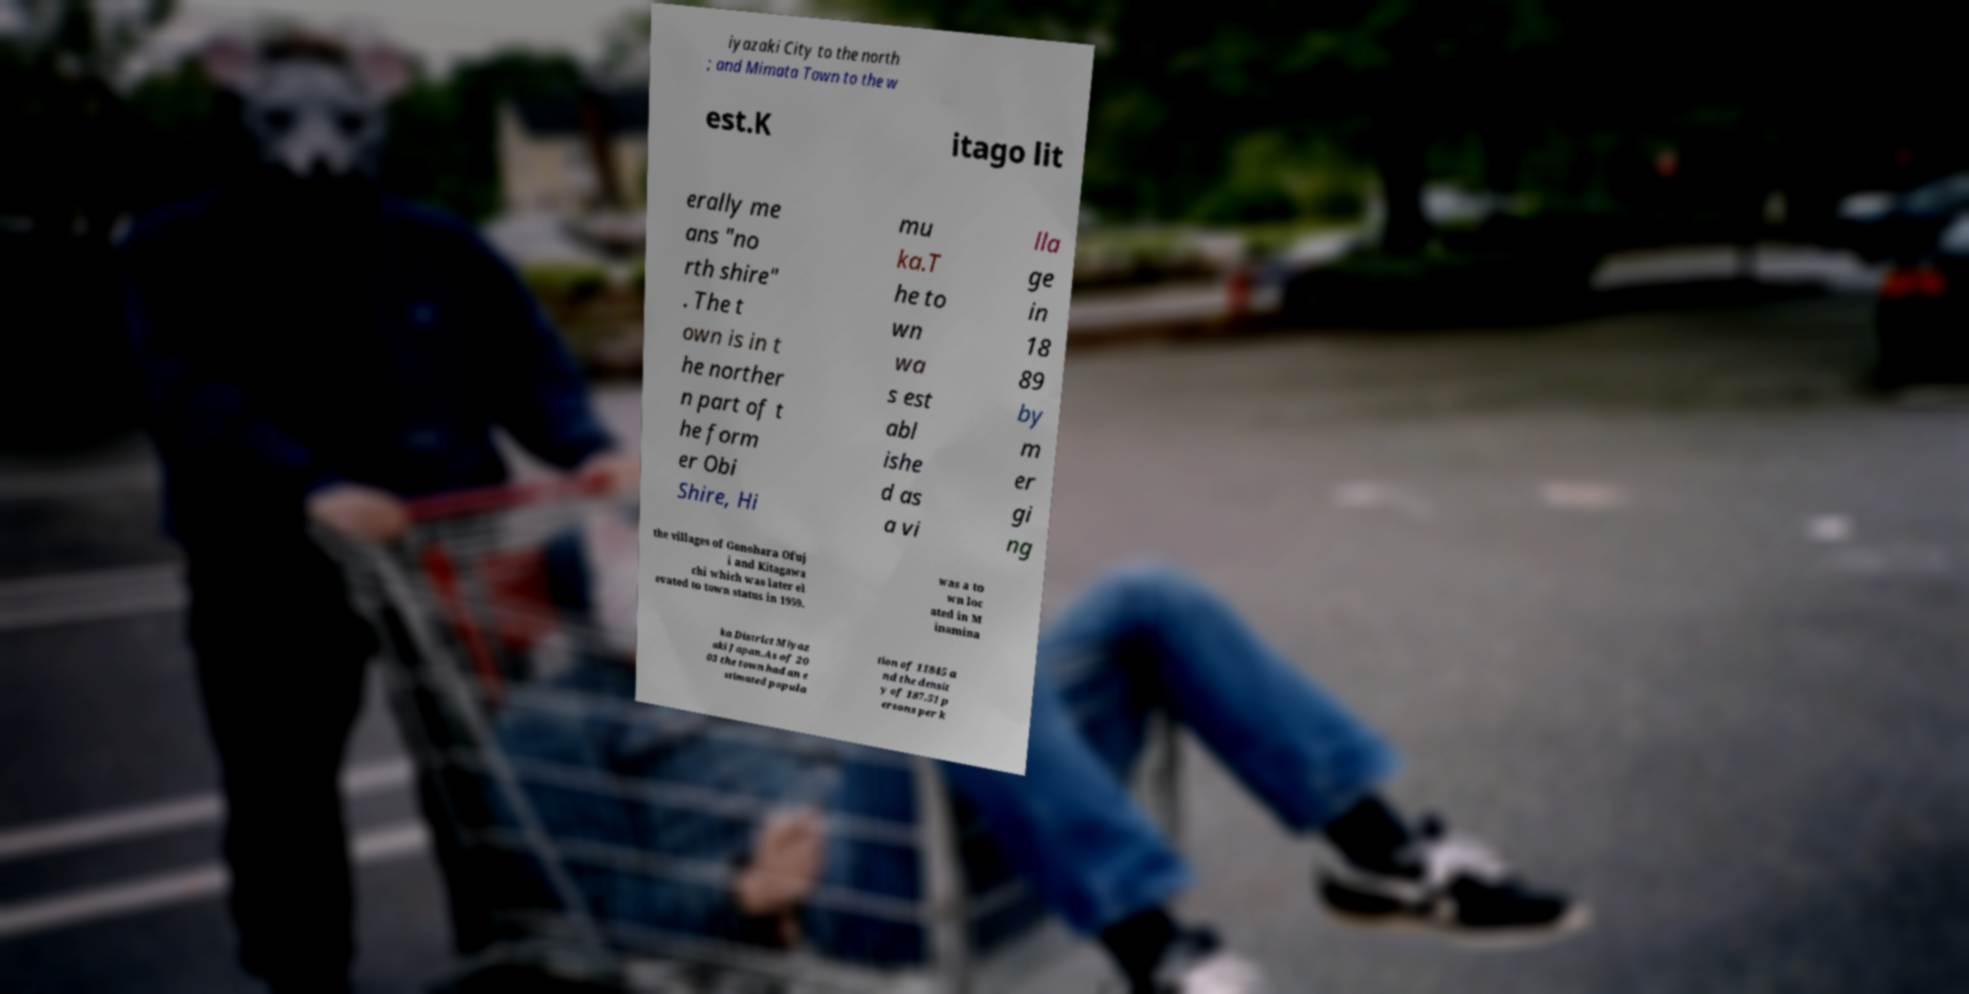Can you accurately transcribe the text from the provided image for me? iyazaki City to the north ; and Mimata Town to the w est.K itago lit erally me ans "no rth shire" . The t own is in t he norther n part of t he form er Obi Shire, Hi mu ka.T he to wn wa s est abl ishe d as a vi lla ge in 18 89 by m er gi ng the villages of Gonohara Ofuj i and Kitagawa chi which was later el evated to town status in 1959. was a to wn loc ated in M inamina ka District Miyaz aki Japan.As of 20 03 the town had an e stimated popula tion of 11845 a nd the densit y of 187.51 p ersons per k 